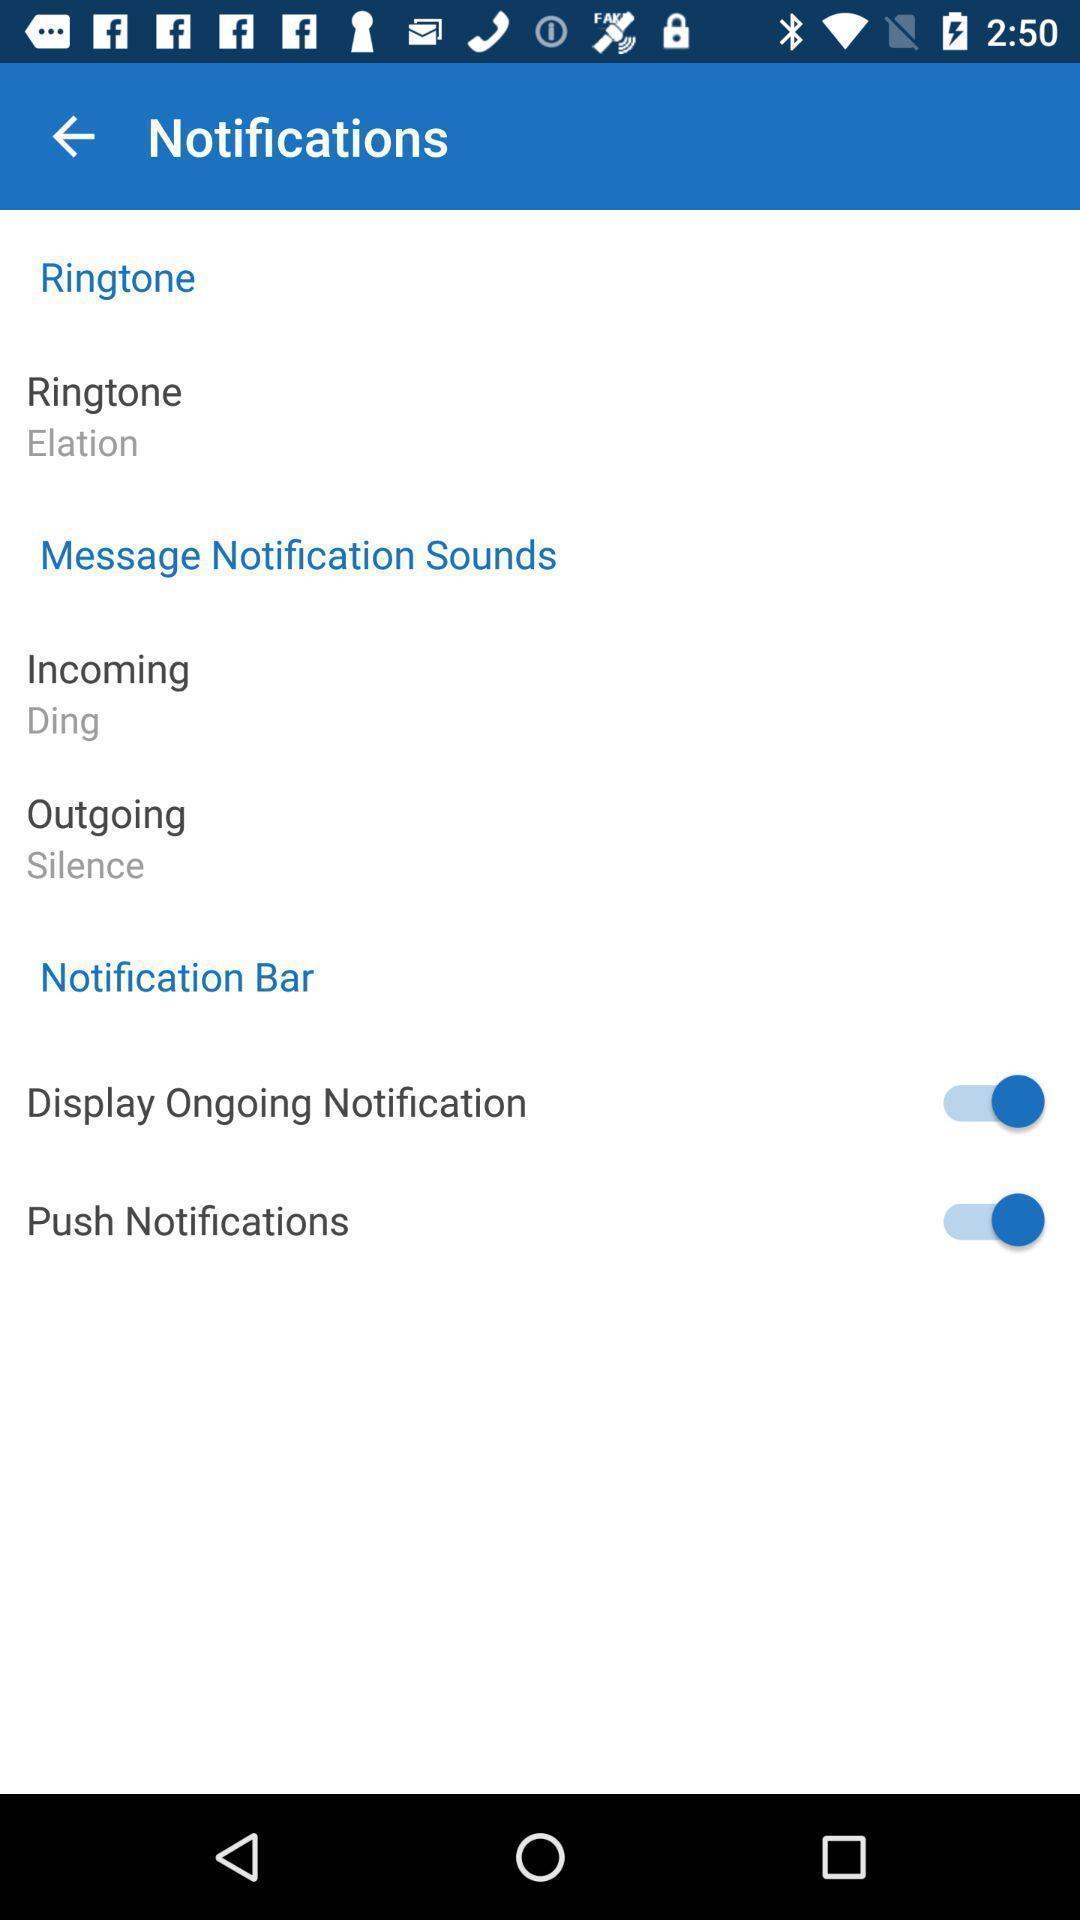What can you discern from this picture? Screen shows notification details. 